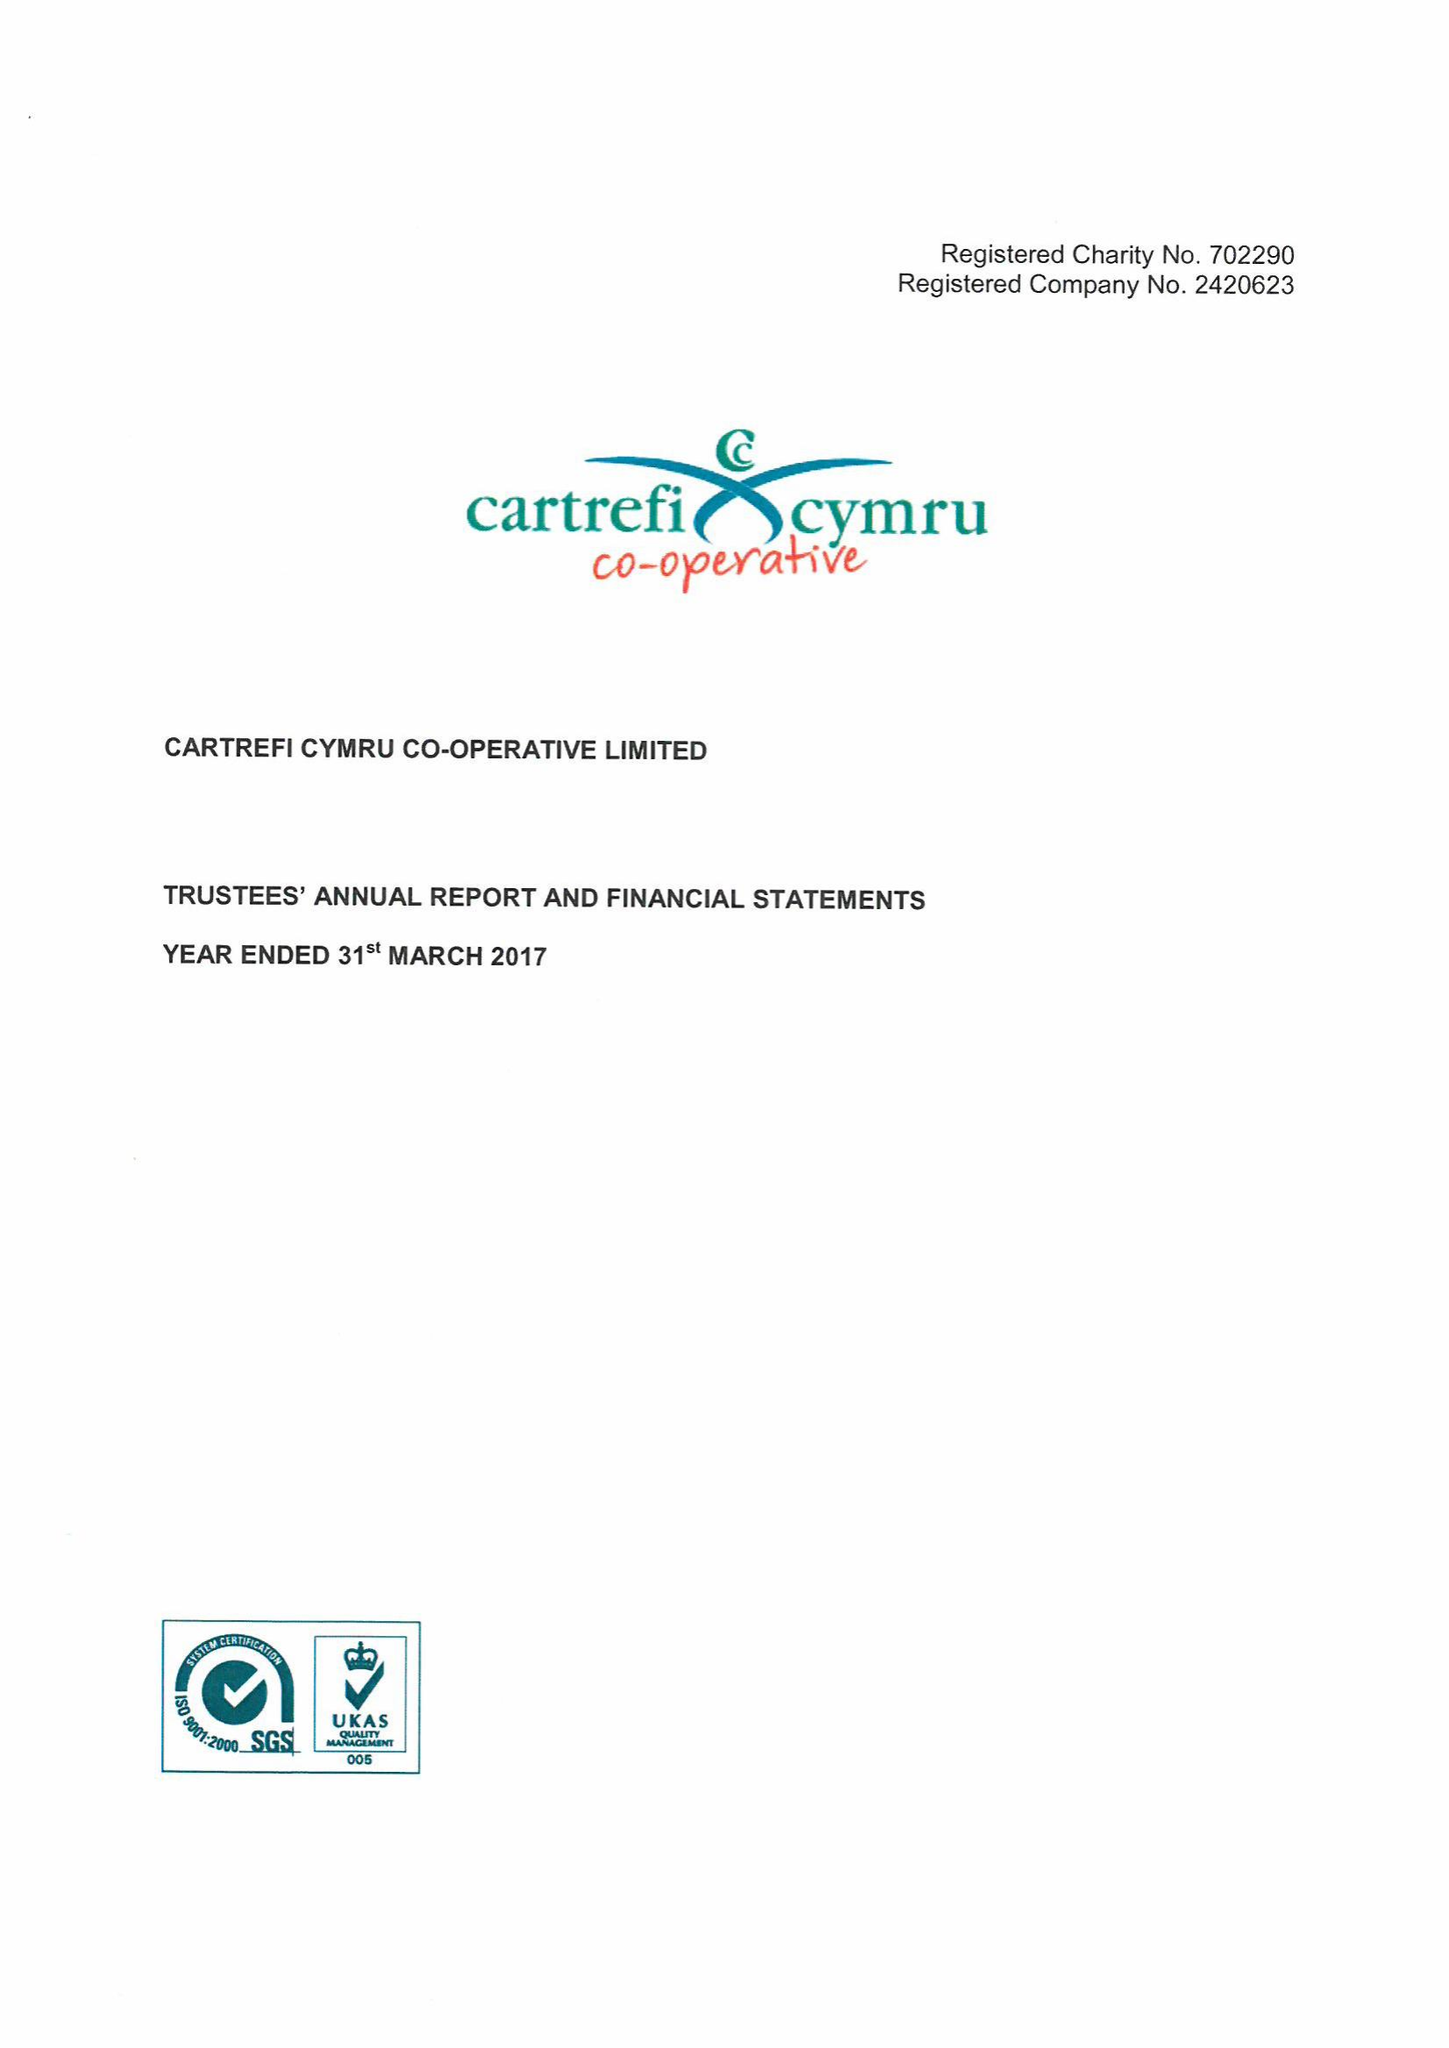What is the value for the charity_name?
Answer the question using a single word or phrase. Cartrefi Cymru Co-Operative Ltd. 